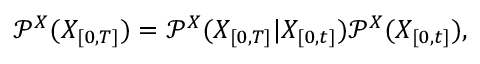Convert formula to latex. <formula><loc_0><loc_0><loc_500><loc_500>\mathcal { P } ^ { X } ( X _ { [ 0 , T ] } ) = \mathcal { P } ^ { X } ( X _ { [ 0 , T ] } | X _ { [ 0 , t ] } ) \mathcal { P } ^ { X } ( X _ { [ 0 , t ] } ) ,</formula> 